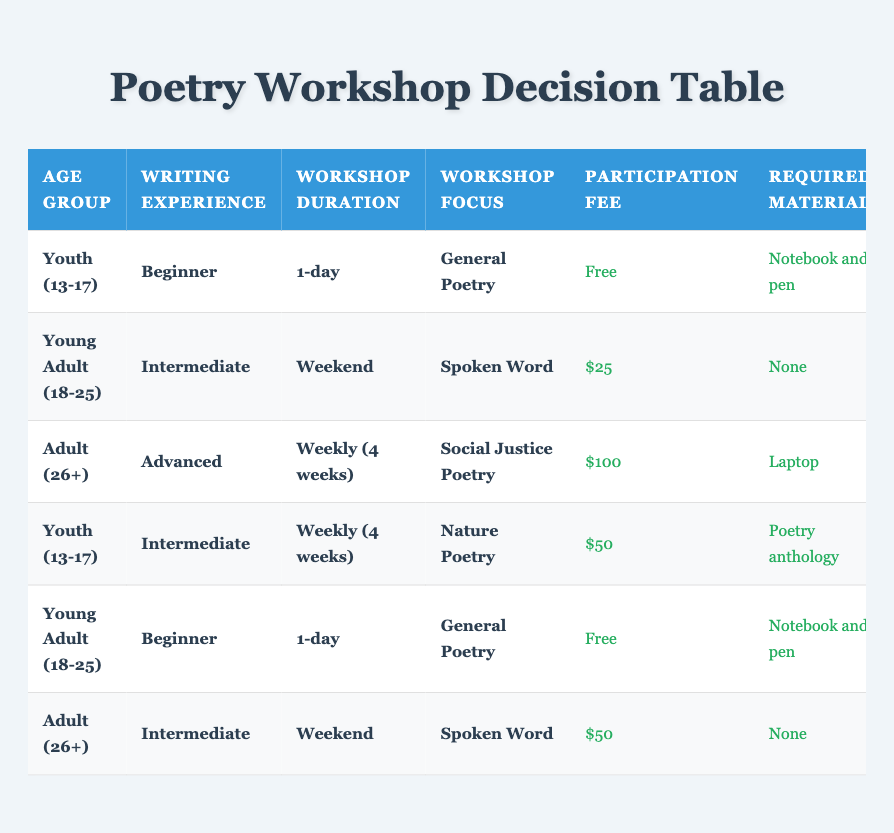What is the participation fee for youth participants with beginner experience in a 1-day General Poetry workshop? From the table, the row matching "Youth (13-17)", "Beginner", "1-day", and "General Poetry" states that the participation fee is "Free".
Answer: Free How many maximum participants are allowed in the Advanced, Weekly (4 weeks), Social Justice Poetry workshop? Referring to the row for "Adult (26+)", "Advanced", "Weekly (4 weeks)", and "Social Justice Poetry", it shows that the maximum participants allowed is 10.
Answer: 10 Is parental consent required for Young Adults (18-25) attending the Weekend Spoken Word workshop? In the relevant row for "Young Adult (18-25)", "Intermediate", "Weekend", "Spoken Word", it indicates that parental consent is "Not Required".
Answer: No What is the required material for Youth participants in the Intermediate, Weekly (4 weeks) Nature Poetry workshop? Looking at the entry for "Youth (13-17)", "Intermediate", "Weekly (4 weeks)", "Nature Poetry", the required material is "Poetry anthology".
Answer: Poetry anthology If we look at both the Adult workshops, what is the average participation fee? The fees for Adult workshops are $100 for Advanced, Weekly (4 weeks) Social Justice Poetry, and $50 for Intermediate, Weekend Spoken Word. The sum of these fees is $150, and there are 2 workshops, thus the average is $150/2 = $75.
Answer: $75 What culminating activity do Youth participants perform in the 1-day General Poetry workshop? In the row where "Youth (13-17)", "Beginner", "1-day", and "General Poetry" are listed, it shows that the culminating activity is a "School assembly performance".
Answer: School assembly performance Are there more maximum participants allowed in the Beginner, 1-day General Poetry workshop than in the Advanced, Weekly (4 weeks) Social Justice Poetry workshop? The maximum for the Beginner, 1-day General Poetry workshop is 25, while for the Advanced, Weekly (4 weeks) Social Justice Poetry workshop, it is 10. Since 25 is greater than 10, the answer is yes.
Answer: Yes Which age group can participate in the Free workshop without any required materials? The entries for both "Youth (13-17)" and "Young Adult (18-25)" for beginner experiences and 1-day General Poetry workshops mention that they are free, with Young Adult needing no materials - "None".
Answer: Young Adult (18-25) 